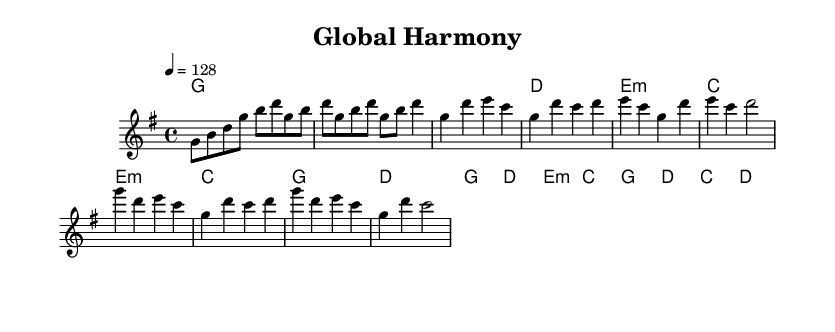What is the key signature of this music? The key signature indicates G major, which has one sharp (F#). This can be identified by looking at the key signature at the beginning of the staff, where the F sharp is indicated.
Answer: G major What is the time signature of this music? The time signature is 4/4, which can be found at the beginning of the piece right after the key signature. This means there are four beats in each measure and a quarter note gets one beat.
Answer: 4/4 What is the tempo marking for this piece? The tempo marking is 4 = 128, which is to be interpreted as the quarter note (the 4 in the notation) equating to a tempo of 128 beats per minute. This information is found at the beginning of the piece under the global settings.
Answer: 128 What chord follows the first measure? The chord that follows the first measure is G major. The chord names in the chord mode right below the melody line indicate the harmony, and the first chord is G.
Answer: G How many distinct sections are present in this piece? There are four distinct sections: Intro, Verse, Pre-Chorus, and Chorus. Each section is indicated by a change in melody and structure, where the patterns in the melody change significantly. This is understood by observing the formatting in the written music.
Answer: Four What is the main key used in the chorus melodies? The main key used in the chorus melodies is G major. Each measure in the chorus section begins with this tonic chord, indicating it strongly centers around G as the main key.
Answer: G major Which type of chords are primarily used in the verse section? The verse section primarily uses major and minor chords. By analyzing the chord mode, we see that the chords change between major (G, D, C) and minor (E minor) which is typical in K-Pop for emotional variety.
Answer: Major and minor chords 